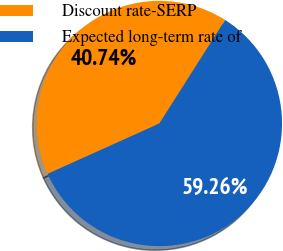Convert chart to OTSL. <chart><loc_0><loc_0><loc_500><loc_500><pie_chart><fcel>Discount rate-SERP<fcel>Expected long-term rate of<nl><fcel>40.74%<fcel>59.26%<nl></chart> 